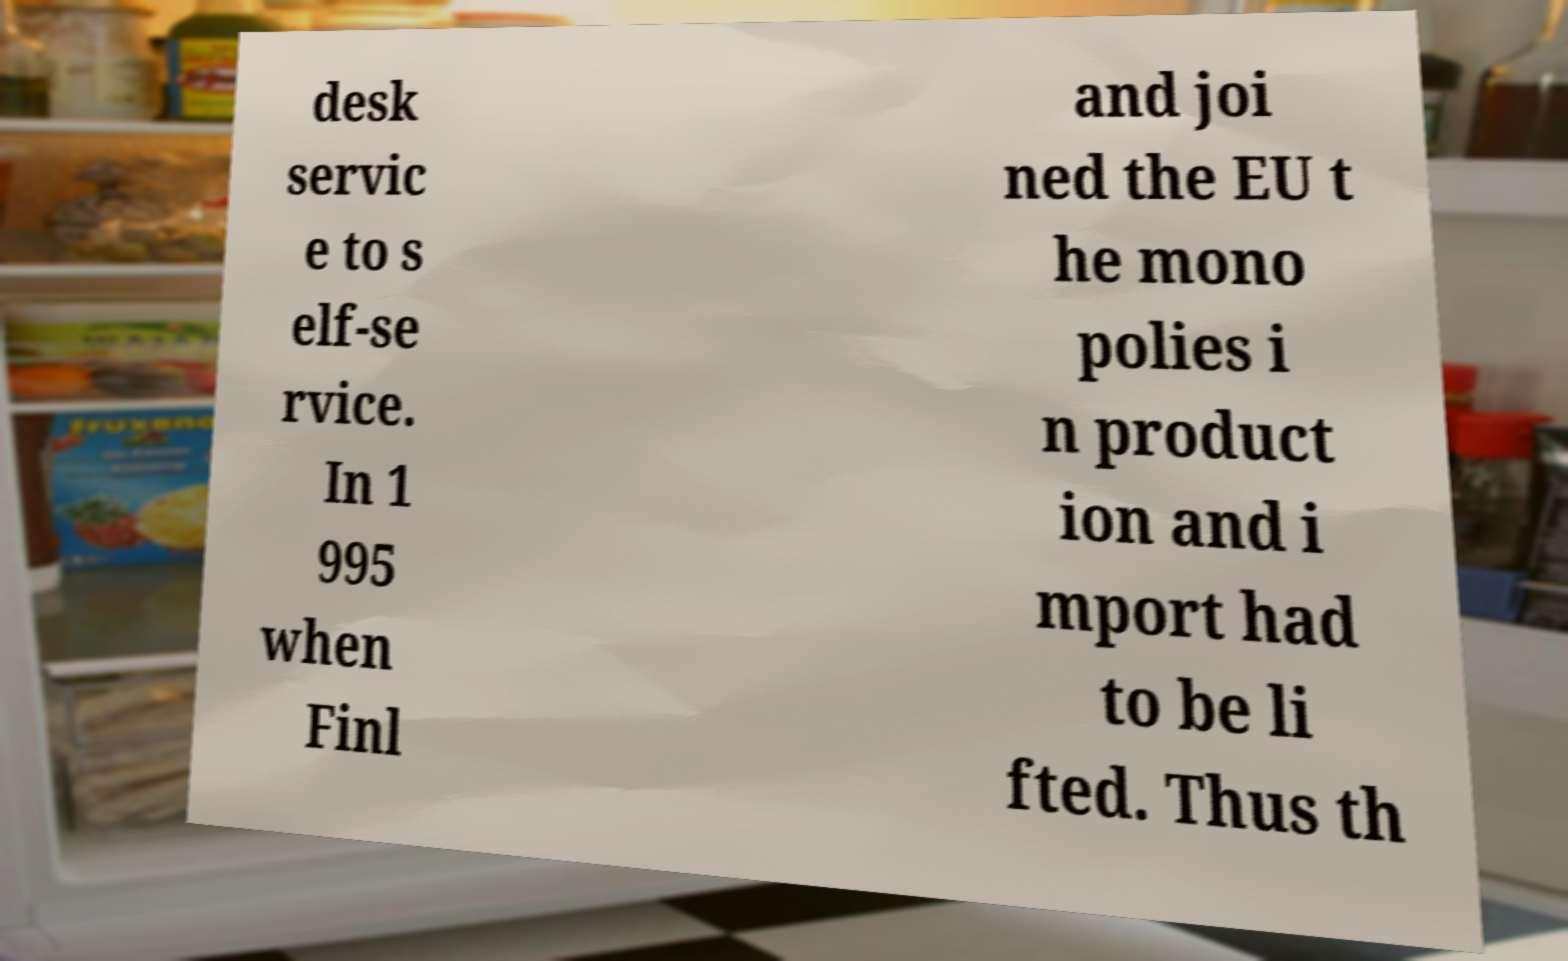Can you accurately transcribe the text from the provided image for me? desk servic e to s elf-se rvice. In 1 995 when Finl and joi ned the EU t he mono polies i n product ion and i mport had to be li fted. Thus th 